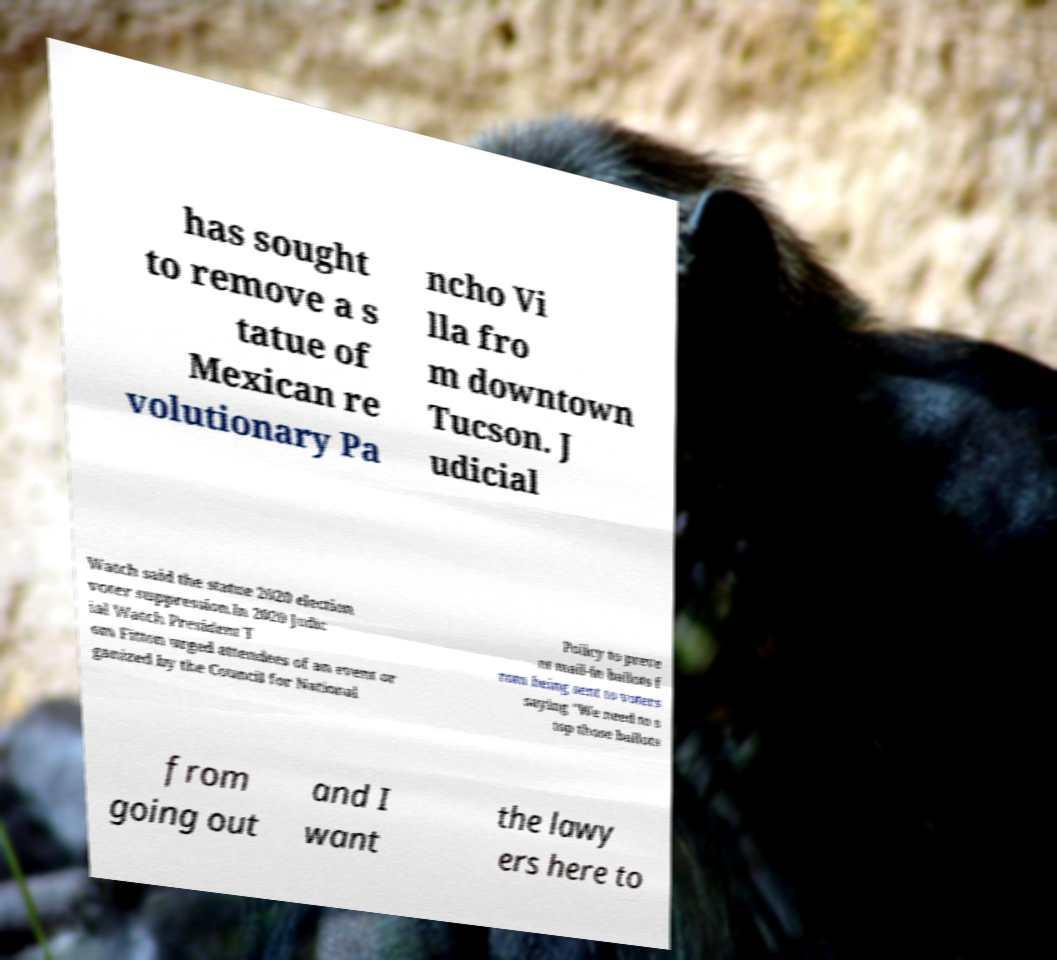I need the written content from this picture converted into text. Can you do that? has sought to remove a s tatue of Mexican re volutionary Pa ncho Vi lla fro m downtown Tucson. J udicial Watch said the statue 2020 election voter suppression.In 2020 Judic ial Watch President T om Fitton urged attendees of an event or ganized by the Council for National Policy to preve nt mail-in ballots f rom being sent to voters saying "We need to s top those ballots from going out and I want the lawy ers here to 